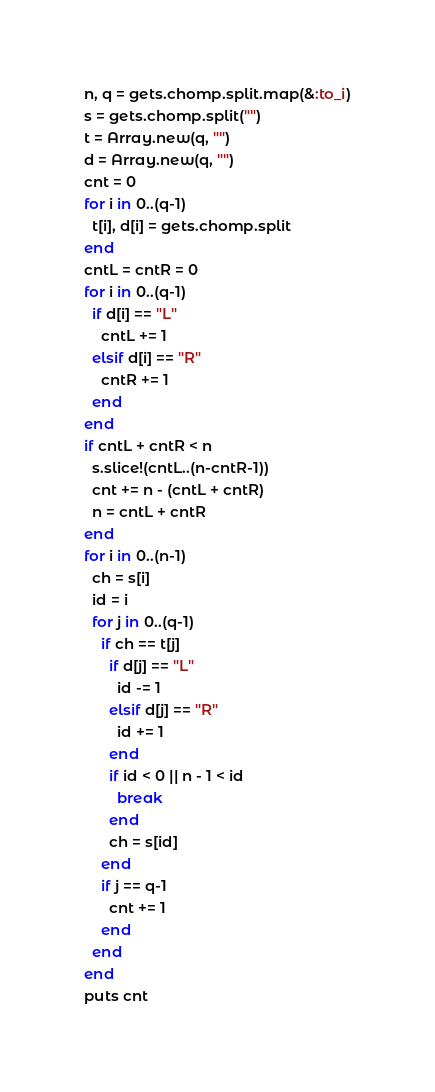<code> <loc_0><loc_0><loc_500><loc_500><_Ruby_>n, q = gets.chomp.split.map(&:to_i)
s = gets.chomp.split("")
t = Array.new(q, "")
d = Array.new(q, "")
cnt = 0
for i in 0..(q-1)
  t[i], d[i] = gets.chomp.split
end
cntL = cntR = 0
for i in 0..(q-1)
  if d[i] == "L"
    cntL += 1
  elsif d[i] == "R"
    cntR += 1
  end
end
if cntL + cntR < n
  s.slice!(cntL..(n-cntR-1))
  cnt += n - (cntL + cntR)
  n = cntL + cntR
end
for i in 0..(n-1)
  ch = s[i]
  id = i
  for j in 0..(q-1)
    if ch == t[j]
      if d[j] == "L"
        id -= 1
      elsif d[j] == "R"
        id += 1
      end
      if id < 0 || n - 1 < id
        break
      end
      ch = s[id]
    end
    if j == q-1
      cnt += 1
    end
  end
end
puts cnt</code> 